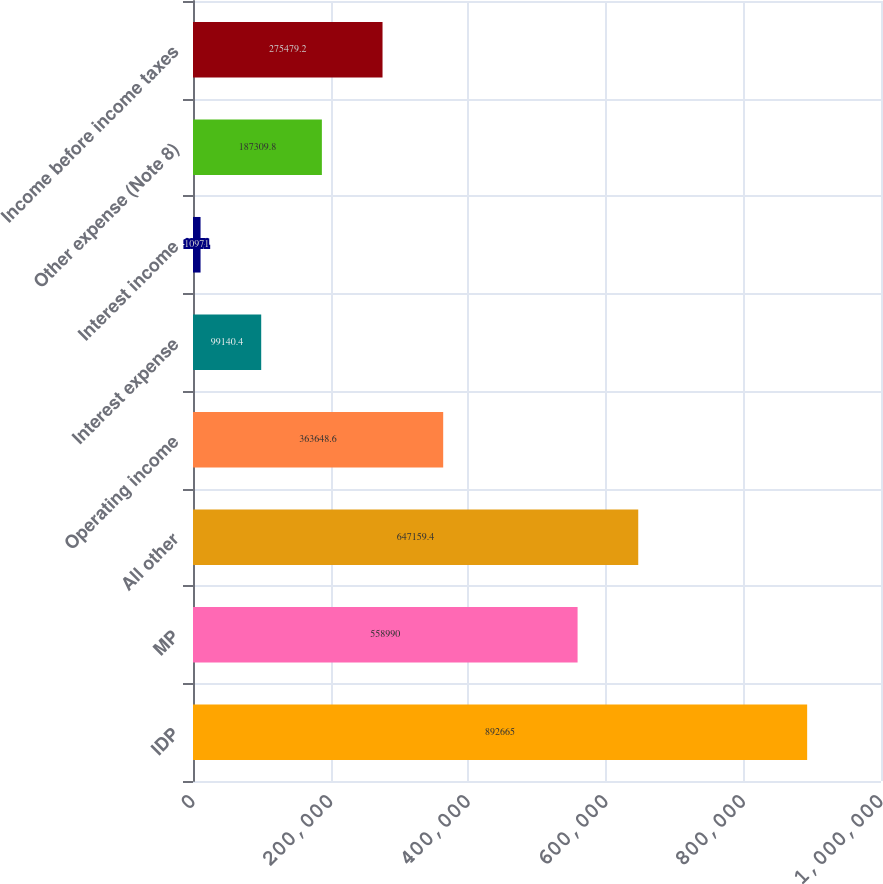<chart> <loc_0><loc_0><loc_500><loc_500><bar_chart><fcel>IDP<fcel>MP<fcel>All other<fcel>Operating income<fcel>Interest expense<fcel>Interest income<fcel>Other expense (Note 8)<fcel>Income before income taxes<nl><fcel>892665<fcel>558990<fcel>647159<fcel>363649<fcel>99140.4<fcel>10971<fcel>187310<fcel>275479<nl></chart> 